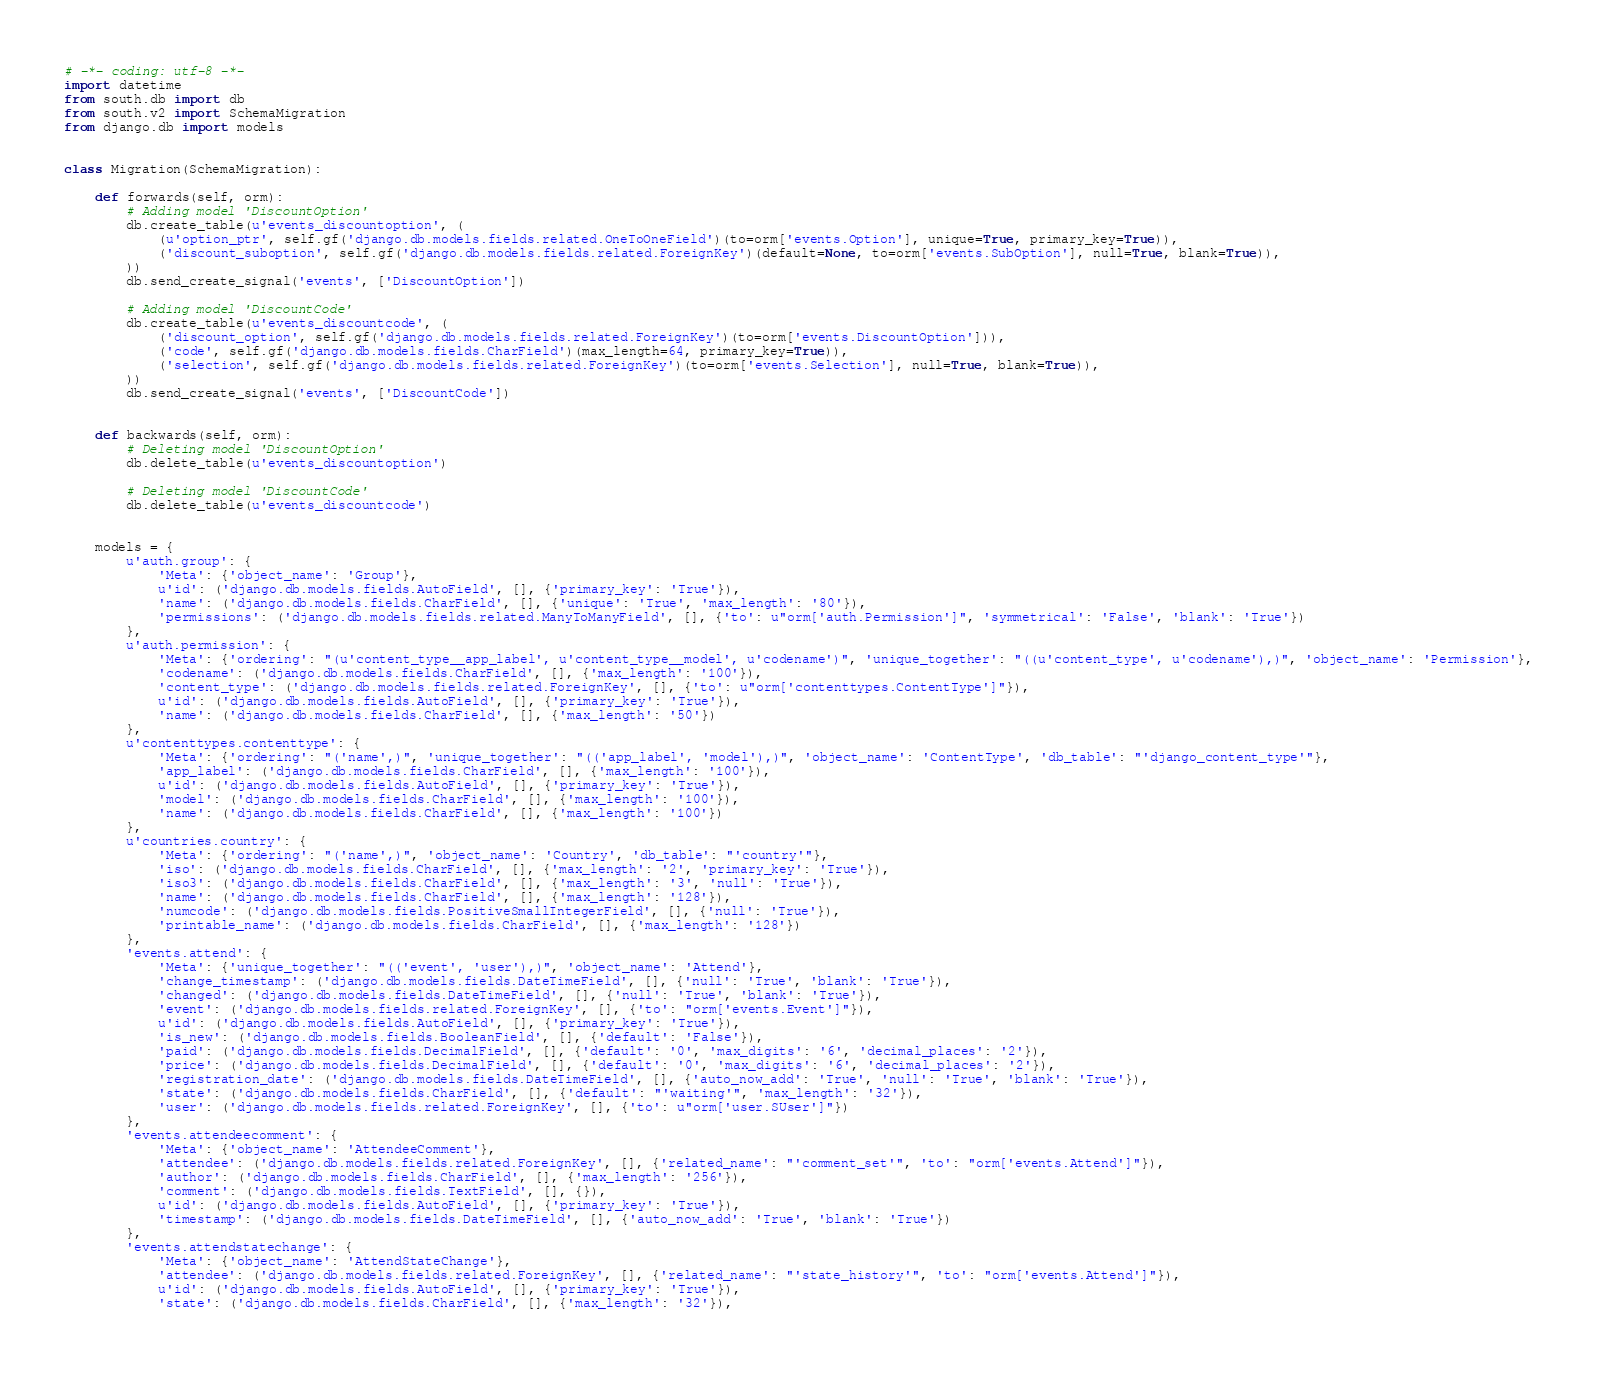Convert code to text. <code><loc_0><loc_0><loc_500><loc_500><_Python_># -*- coding: utf-8 -*-
import datetime
from south.db import db
from south.v2 import SchemaMigration
from django.db import models


class Migration(SchemaMigration):

    def forwards(self, orm):
        # Adding model 'DiscountOption'
        db.create_table(u'events_discountoption', (
            (u'option_ptr', self.gf('django.db.models.fields.related.OneToOneField')(to=orm['events.Option'], unique=True, primary_key=True)),
            ('discount_suboption', self.gf('django.db.models.fields.related.ForeignKey')(default=None, to=orm['events.SubOption'], null=True, blank=True)),
        ))
        db.send_create_signal('events', ['DiscountOption'])

        # Adding model 'DiscountCode'
        db.create_table(u'events_discountcode', (
            ('discount_option', self.gf('django.db.models.fields.related.ForeignKey')(to=orm['events.DiscountOption'])),
            ('code', self.gf('django.db.models.fields.CharField')(max_length=64, primary_key=True)),
            ('selection', self.gf('django.db.models.fields.related.ForeignKey')(to=orm['events.Selection'], null=True, blank=True)),
        ))
        db.send_create_signal('events', ['DiscountCode'])


    def backwards(self, orm):
        # Deleting model 'DiscountOption'
        db.delete_table(u'events_discountoption')

        # Deleting model 'DiscountCode'
        db.delete_table(u'events_discountcode')


    models = {
        u'auth.group': {
            'Meta': {'object_name': 'Group'},
            u'id': ('django.db.models.fields.AutoField', [], {'primary_key': 'True'}),
            'name': ('django.db.models.fields.CharField', [], {'unique': 'True', 'max_length': '80'}),
            'permissions': ('django.db.models.fields.related.ManyToManyField', [], {'to': u"orm['auth.Permission']", 'symmetrical': 'False', 'blank': 'True'})
        },
        u'auth.permission': {
            'Meta': {'ordering': "(u'content_type__app_label', u'content_type__model', u'codename')", 'unique_together': "((u'content_type', u'codename'),)", 'object_name': 'Permission'},
            'codename': ('django.db.models.fields.CharField', [], {'max_length': '100'}),
            'content_type': ('django.db.models.fields.related.ForeignKey', [], {'to': u"orm['contenttypes.ContentType']"}),
            u'id': ('django.db.models.fields.AutoField', [], {'primary_key': 'True'}),
            'name': ('django.db.models.fields.CharField', [], {'max_length': '50'})
        },
        u'contenttypes.contenttype': {
            'Meta': {'ordering': "('name',)", 'unique_together': "(('app_label', 'model'),)", 'object_name': 'ContentType', 'db_table': "'django_content_type'"},
            'app_label': ('django.db.models.fields.CharField', [], {'max_length': '100'}),
            u'id': ('django.db.models.fields.AutoField', [], {'primary_key': 'True'}),
            'model': ('django.db.models.fields.CharField', [], {'max_length': '100'}),
            'name': ('django.db.models.fields.CharField', [], {'max_length': '100'})
        },
        u'countries.country': {
            'Meta': {'ordering': "('name',)", 'object_name': 'Country', 'db_table': "'country'"},
            'iso': ('django.db.models.fields.CharField', [], {'max_length': '2', 'primary_key': 'True'}),
            'iso3': ('django.db.models.fields.CharField', [], {'max_length': '3', 'null': 'True'}),
            'name': ('django.db.models.fields.CharField', [], {'max_length': '128'}),
            'numcode': ('django.db.models.fields.PositiveSmallIntegerField', [], {'null': 'True'}),
            'printable_name': ('django.db.models.fields.CharField', [], {'max_length': '128'})
        },
        'events.attend': {
            'Meta': {'unique_together': "(('event', 'user'),)", 'object_name': 'Attend'},
            'change_timestamp': ('django.db.models.fields.DateTimeField', [], {'null': 'True', 'blank': 'True'}),
            'changed': ('django.db.models.fields.DateTimeField', [], {'null': 'True', 'blank': 'True'}),
            'event': ('django.db.models.fields.related.ForeignKey', [], {'to': "orm['events.Event']"}),
            u'id': ('django.db.models.fields.AutoField', [], {'primary_key': 'True'}),
            'is_new': ('django.db.models.fields.BooleanField', [], {'default': 'False'}),
            'paid': ('django.db.models.fields.DecimalField', [], {'default': '0', 'max_digits': '6', 'decimal_places': '2'}),
            'price': ('django.db.models.fields.DecimalField', [], {'default': '0', 'max_digits': '6', 'decimal_places': '2'}),
            'registration_date': ('django.db.models.fields.DateTimeField', [], {'auto_now_add': 'True', 'null': 'True', 'blank': 'True'}),
            'state': ('django.db.models.fields.CharField', [], {'default': "'waiting'", 'max_length': '32'}),
            'user': ('django.db.models.fields.related.ForeignKey', [], {'to': u"orm['user.SUser']"})
        },
        'events.attendeecomment': {
            'Meta': {'object_name': 'AttendeeComment'},
            'attendee': ('django.db.models.fields.related.ForeignKey', [], {'related_name': "'comment_set'", 'to': "orm['events.Attend']"}),
            'author': ('django.db.models.fields.CharField', [], {'max_length': '256'}),
            'comment': ('django.db.models.fields.TextField', [], {}),
            u'id': ('django.db.models.fields.AutoField', [], {'primary_key': 'True'}),
            'timestamp': ('django.db.models.fields.DateTimeField', [], {'auto_now_add': 'True', 'blank': 'True'})
        },
        'events.attendstatechange': {
            'Meta': {'object_name': 'AttendStateChange'},
            'attendee': ('django.db.models.fields.related.ForeignKey', [], {'related_name': "'state_history'", 'to': "orm['events.Attend']"}),
            u'id': ('django.db.models.fields.AutoField', [], {'primary_key': 'True'}),
            'state': ('django.db.models.fields.CharField', [], {'max_length': '32'}),</code> 